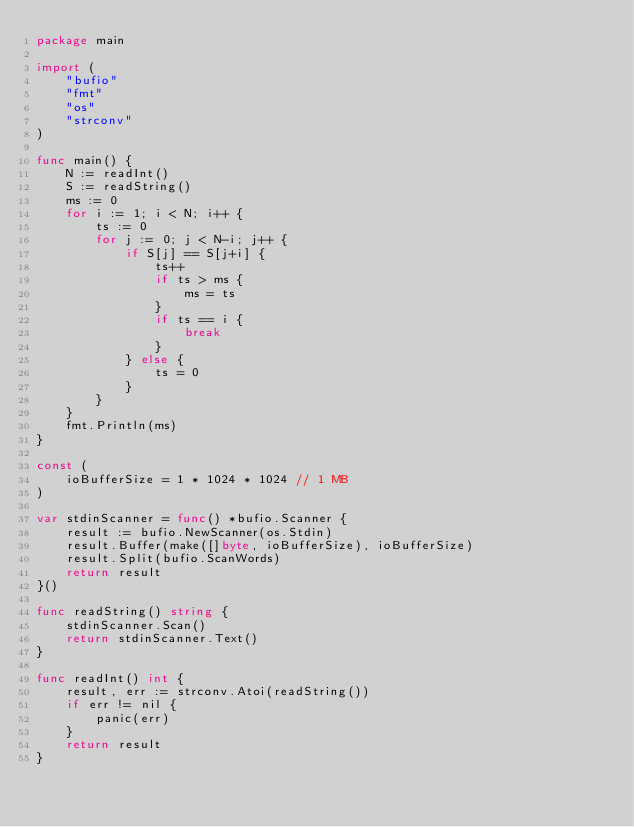Convert code to text. <code><loc_0><loc_0><loc_500><loc_500><_Go_>package main

import (
	"bufio"
	"fmt"
	"os"
	"strconv"
)

func main() {
	N := readInt()
	S := readString()
	ms := 0
	for i := 1; i < N; i++ {
		ts := 0
		for j := 0; j < N-i; j++ {
			if S[j] == S[j+i] {
				ts++
				if ts > ms {
					ms = ts
				}
				if ts == i {
					break
				}
			} else {
				ts = 0
			}
		}
	}
	fmt.Println(ms)
}

const (
	ioBufferSize = 1 * 1024 * 1024 // 1 MB
)

var stdinScanner = func() *bufio.Scanner {
	result := bufio.NewScanner(os.Stdin)
	result.Buffer(make([]byte, ioBufferSize), ioBufferSize)
	result.Split(bufio.ScanWords)
	return result
}()

func readString() string {
	stdinScanner.Scan()
	return stdinScanner.Text()
}

func readInt() int {
	result, err := strconv.Atoi(readString())
	if err != nil {
		panic(err)
	}
	return result
}
</code> 